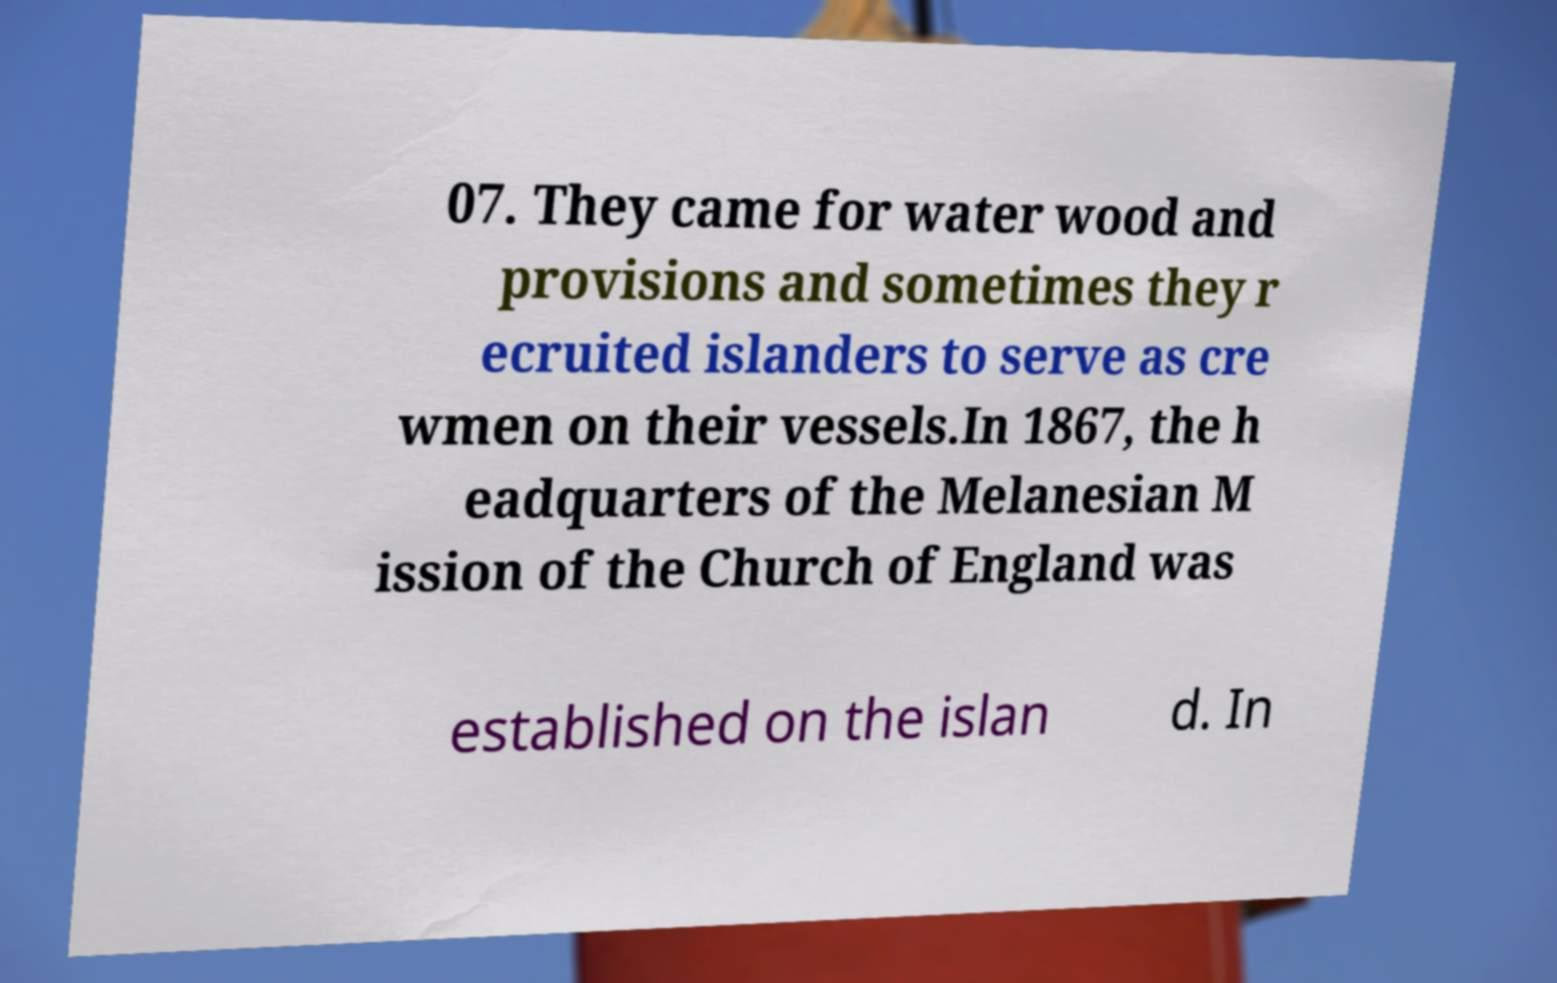There's text embedded in this image that I need extracted. Can you transcribe it verbatim? 07. They came for water wood and provisions and sometimes they r ecruited islanders to serve as cre wmen on their vessels.In 1867, the h eadquarters of the Melanesian M ission of the Church of England was established on the islan d. In 